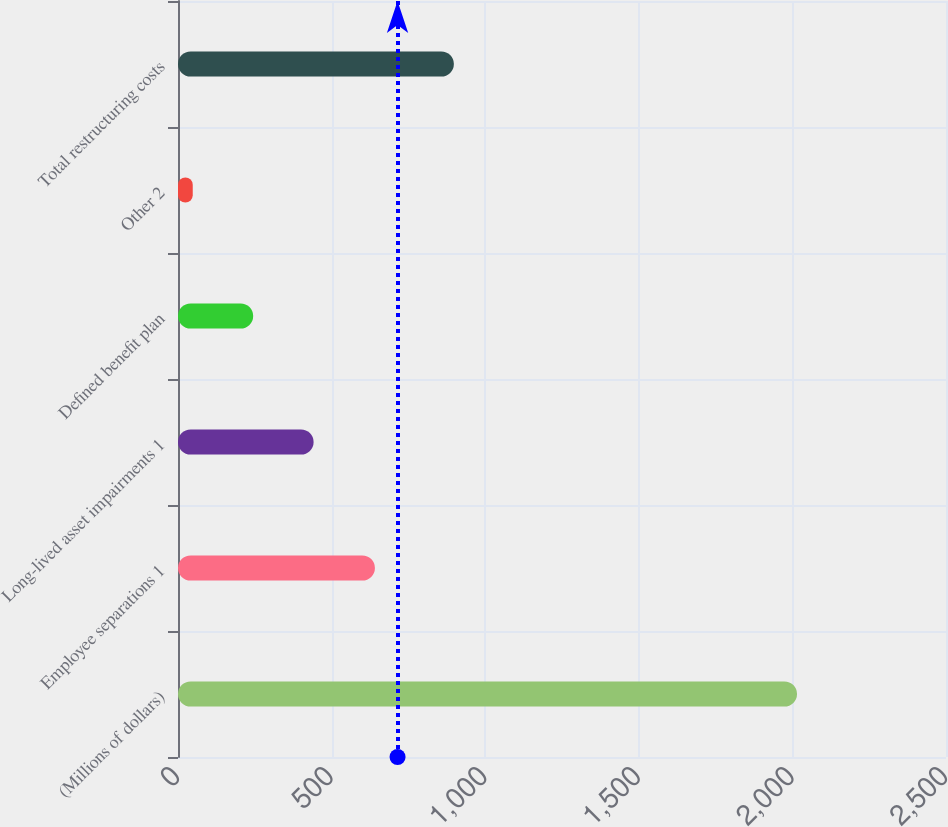Convert chart to OTSL. <chart><loc_0><loc_0><loc_500><loc_500><bar_chart><fcel>(Millions of dollars)<fcel>Employee separations 1<fcel>Long-lived asset impairments 1<fcel>Defined benefit plan<fcel>Other 2<fcel>Total restructuring costs<nl><fcel>2015<fcel>641<fcel>441.4<fcel>244.7<fcel>48<fcel>898<nl></chart> 